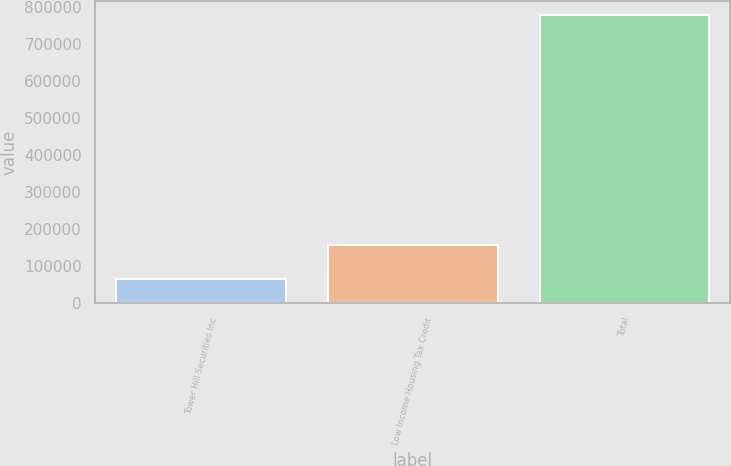<chart> <loc_0><loc_0><loc_500><loc_500><bar_chart><fcel>Tower Hill Securities Inc<fcel>Low Income Housing Tax Credit<fcel>Total<nl><fcel>65000<fcel>157754<fcel>777250<nl></chart> 